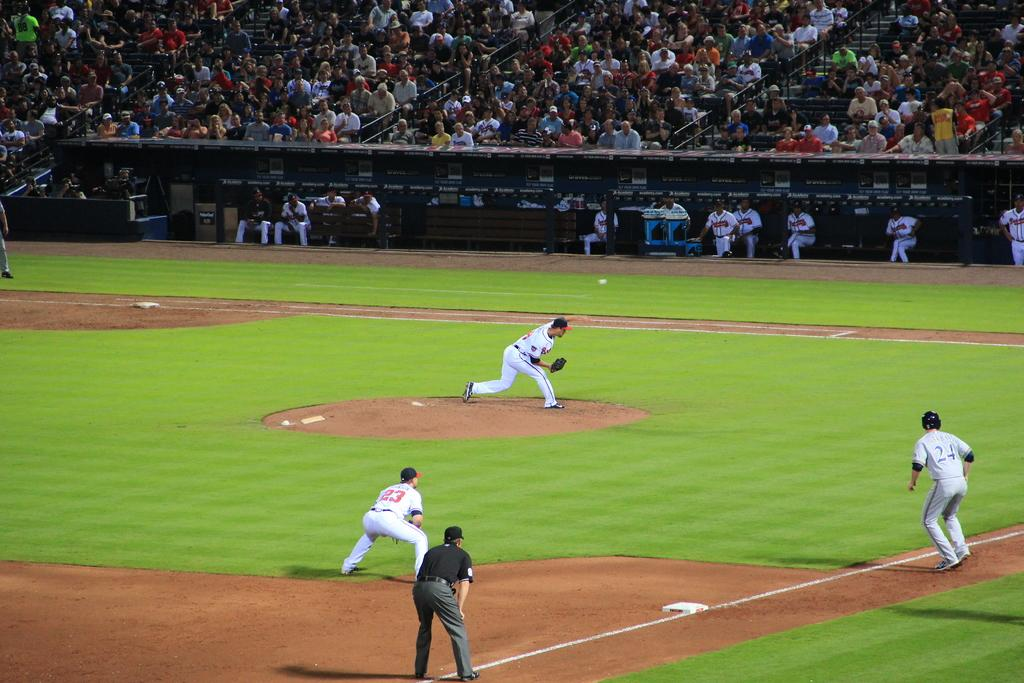<image>
Relay a brief, clear account of the picture shown. The pitcher throws a ball during a baseball game. 